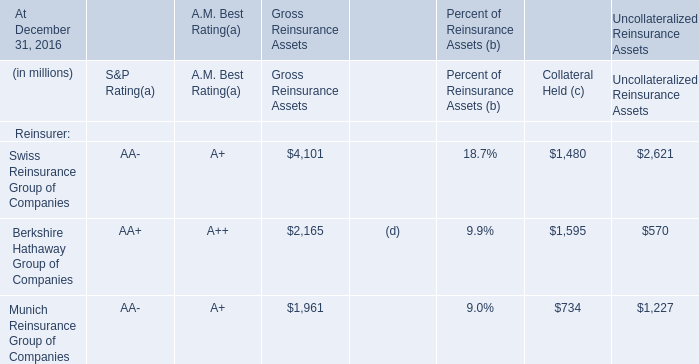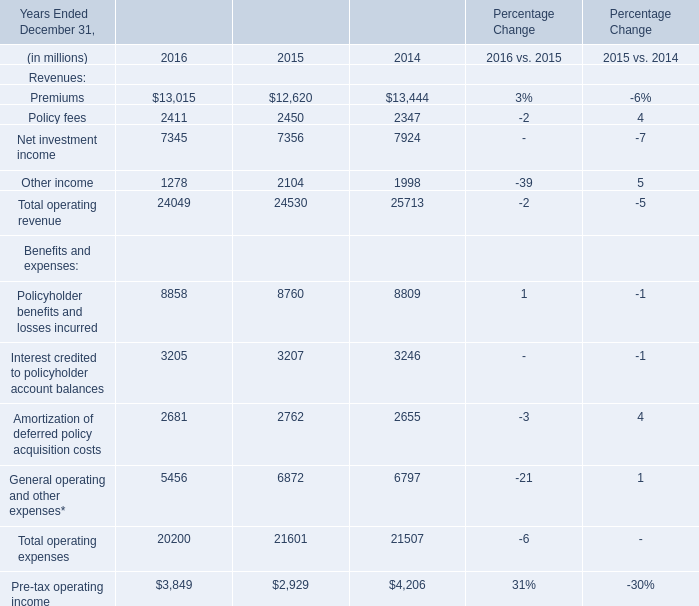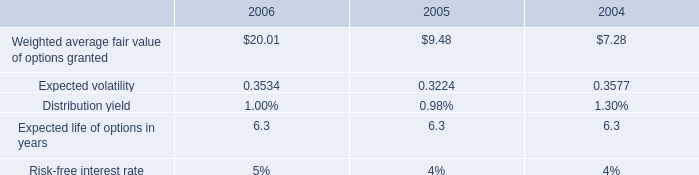What is the sum of Premiums of Percentage Change 2016, Munich Reinsurance Group of Companies of Uncollateralized Reinsurance Assets, and Net investment income of Percentage Change 2016 ? 
Computations: ((13015.0 + 1227.0) + 7345.0)
Answer: 21587.0. 